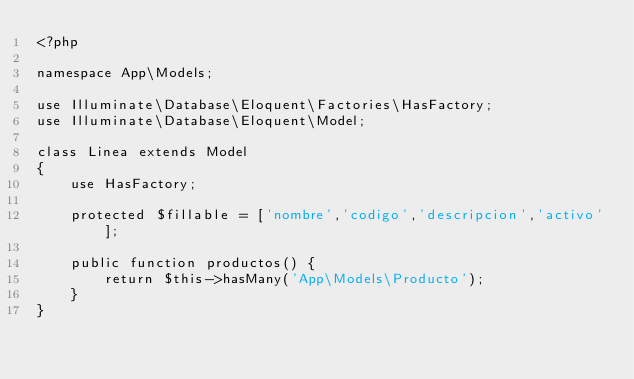<code> <loc_0><loc_0><loc_500><loc_500><_PHP_><?php

namespace App\Models;

use Illuminate\Database\Eloquent\Factories\HasFactory;
use Illuminate\Database\Eloquent\Model;

class Linea extends Model
{
    use HasFactory;

    protected $fillable = ['nombre','codigo','descripcion','activo'];

    public function productos() {
        return $this->hasMany('App\Models\Producto');
    }
}
</code> 